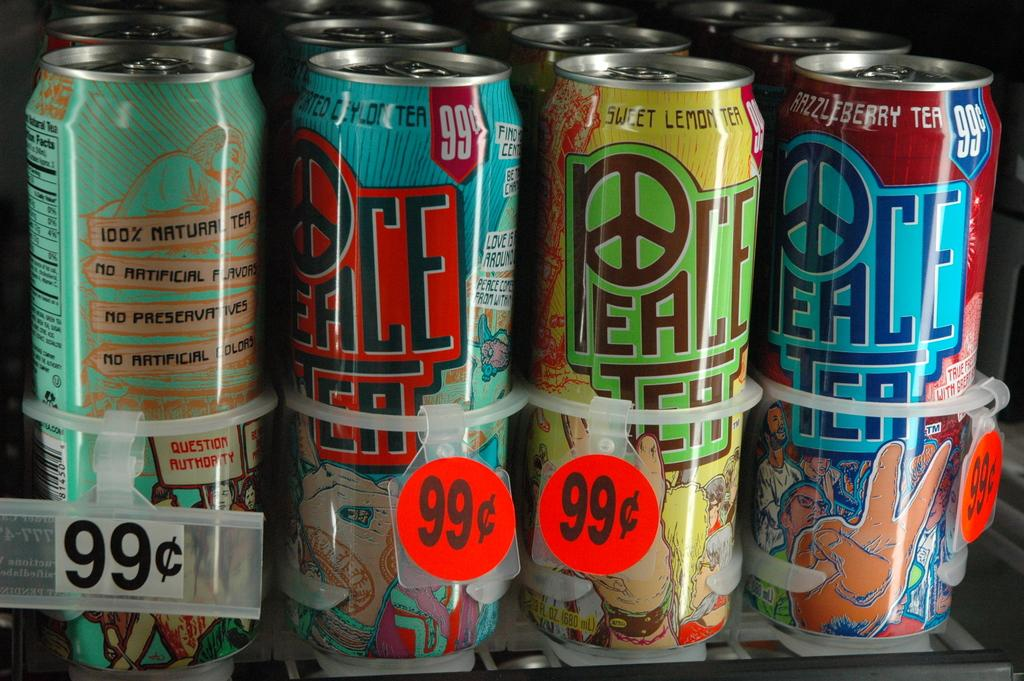<image>
Relay a brief, clear account of the picture shown. Different flavors of Peace Tea on sale for 99 cents 